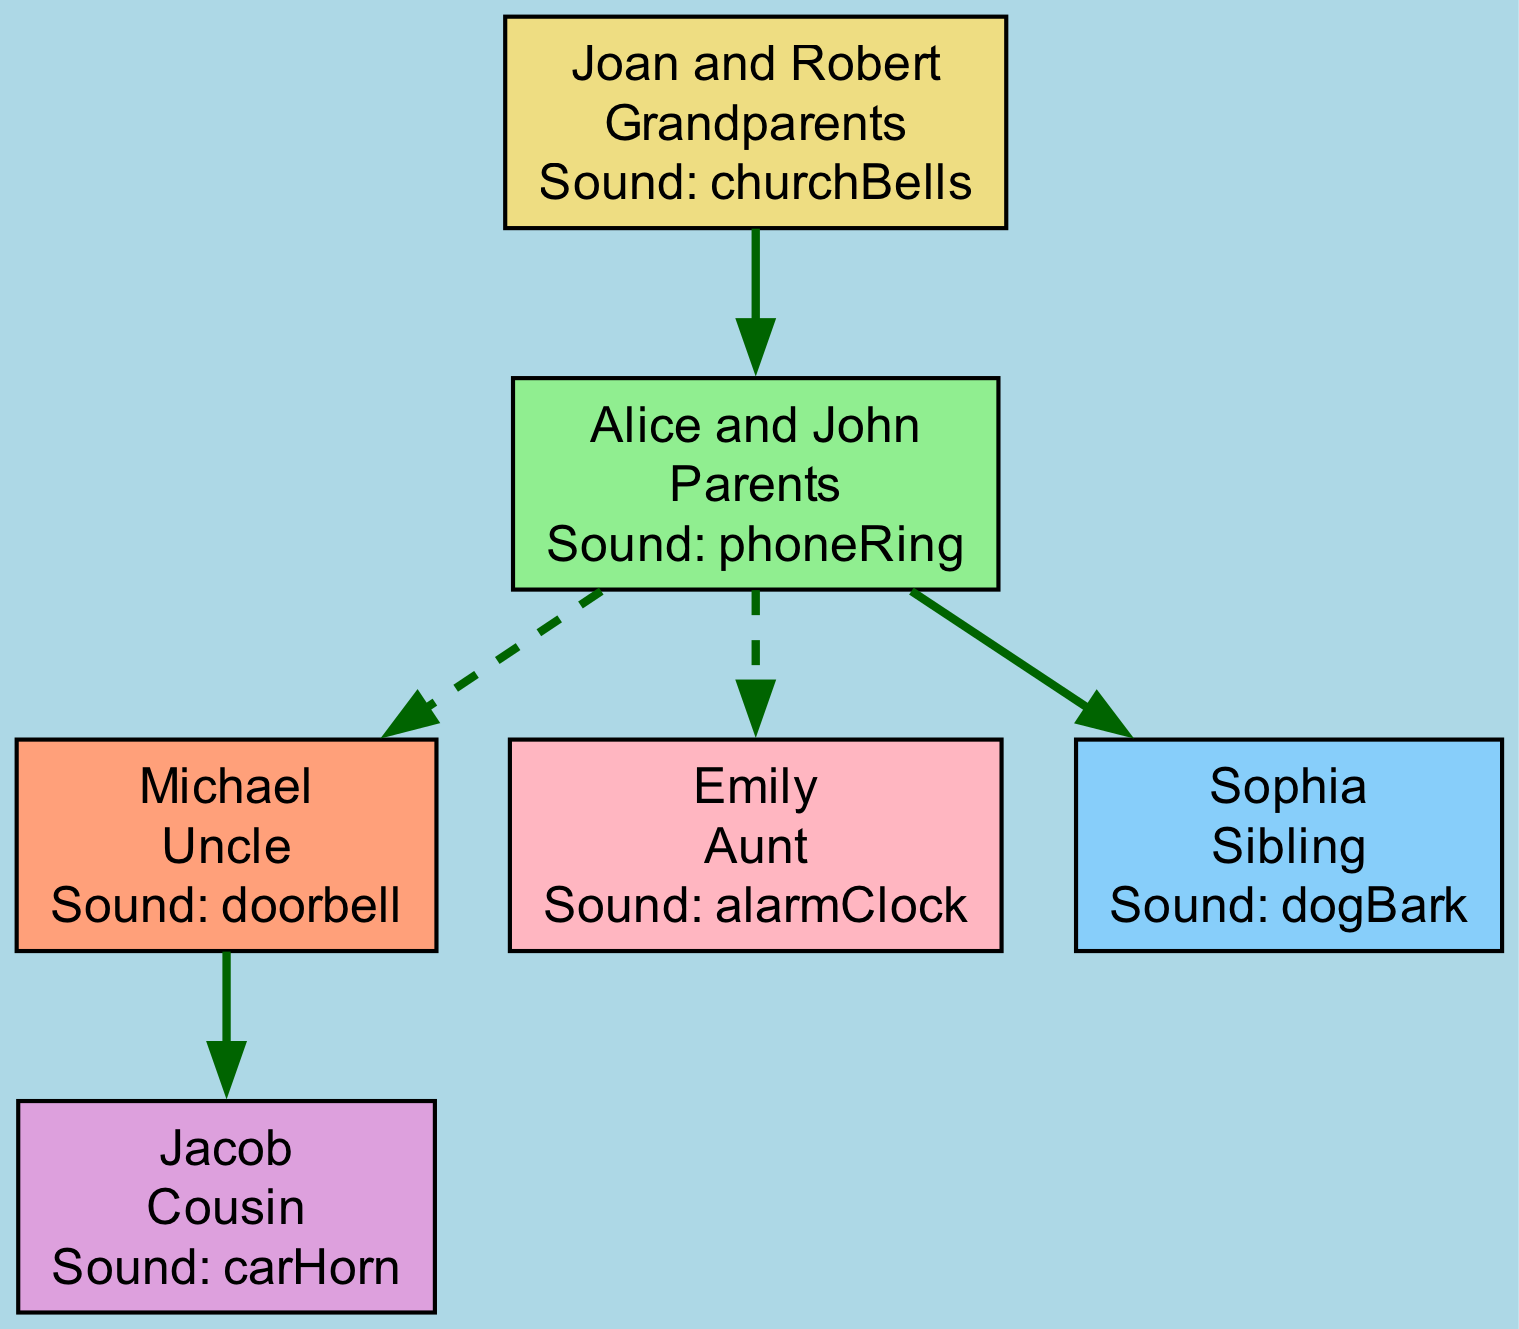What sound cue is associated with the Grandparents? The diagram shows that the Grandparents are represented by the name "Joan and Robert," and their associated sound cue is "churchBells." Therefore, the answer is directly taken from the node representing the Grandparents.
Answer: churchBells How many edges are in the diagram? By analyzing the connections (edges) made between the different family members in the diagram, we can count that there are five distinct edges connecting the various nodes.
Answer: 5 What is the relationship between Alice and Michael? The diagram indicates that Alice (Parents) and Michael (Uncle) are connected through a sibling relationship, as their respective parents are siblings. Thus, they share a familial connection in the diagram.
Answer: sibling What sound cue does Sophia imitate? The node representing Sophia (Sibling) indicates that her sound cue is "dogBark." This information is directly available on her node in the diagram.
Answer: dogBark Who is the parent of Jacob? The edges in the diagram show that Jacob (Cousin) is connected to Michael (Uncle) through a parent-offspring relationship. Since Jacob is listed under Uncle, we conclude Michael is his parent.
Answer: Michael What color represents the Sibling node? The Sibling node (Sophia) in the diagram is displayed with the color "lightskyblue." This color is noted in the node's visual representation, making it simple to identify.
Answer: lightskyblue How many grandparents are listed in the diagram? The diagram explicitly lists one node for Grandparents, which includes Joan and Robert as a single entity. Thus, counting them gives us one entry for grandparents in the family tree.
Answer: 1 What sound cue does Emily imitate? By examining the node that represents Emily (Aunt), we see her sound cue is noted as "alarmClock." This is directly associated with her representation in the diagram.
Answer: alarmClock Which node represents the parents in the diagram? The "Parents" node in the diagram represents Alice and John, which is explicitly labeled. This label makes it easy to identify the parents within the family network.
Answer: Alice and John 